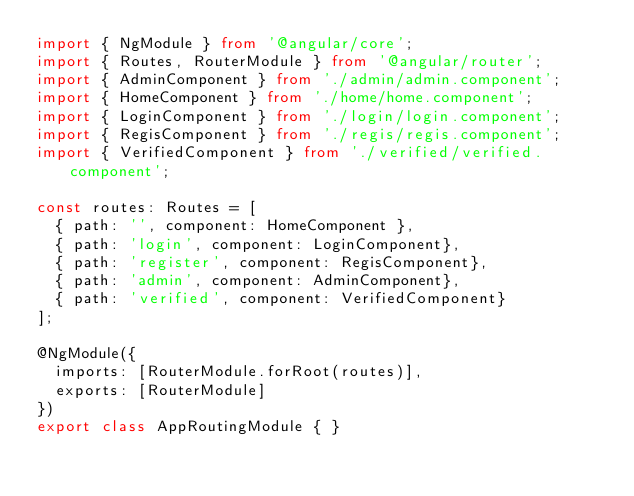Convert code to text. <code><loc_0><loc_0><loc_500><loc_500><_TypeScript_>import { NgModule } from '@angular/core';
import { Routes, RouterModule } from '@angular/router';
import { AdminComponent } from './admin/admin.component';
import { HomeComponent } from './home/home.component';
import { LoginComponent } from './login/login.component';
import { RegisComponent } from './regis/regis.component';
import { VerifiedComponent } from './verified/verified.component';

const routes: Routes = [
  { path: '', component: HomeComponent },
  { path: 'login', component: LoginComponent},
  { path: 'register', component: RegisComponent},
  { path: 'admin', component: AdminComponent},
  { path: 'verified', component: VerifiedComponent}
];

@NgModule({
  imports: [RouterModule.forRoot(routes)],
  exports: [RouterModule]
})
export class AppRoutingModule { }
</code> 